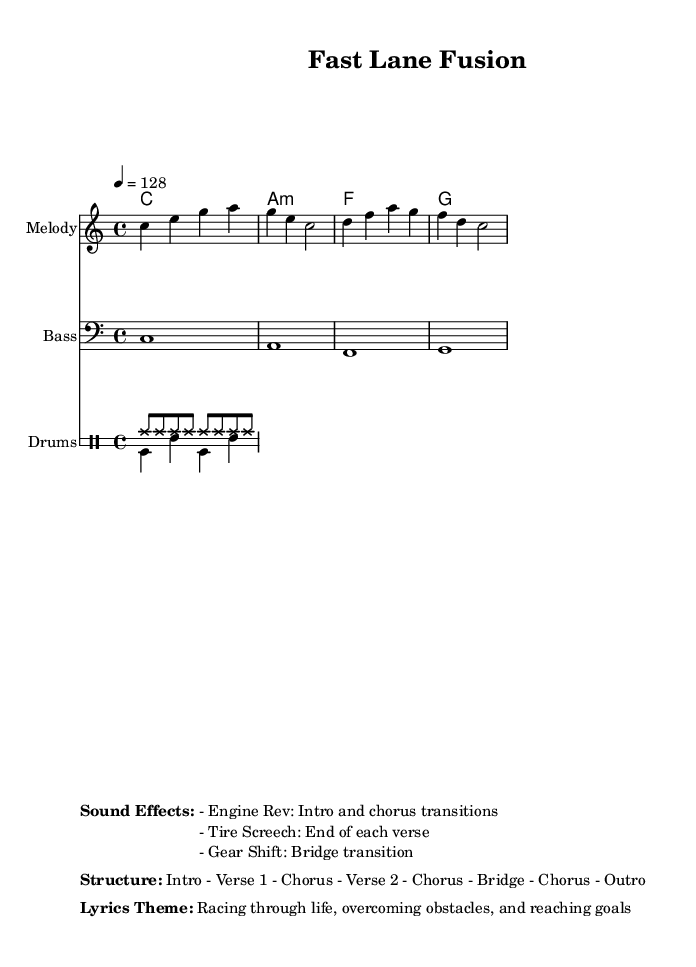What is the key signature of this music? The key signature is indicated as C major, which is shown near the beginning of the sheet music. It has no sharps or flats, confirming the key of C major.
Answer: C major What is the time signature of the music? The time signature is shown right after the key signature, indicated by the number of beats per measure and the note that gets the beat. In this case, it is 4/4, meaning there are four beats in each measure and the quarter note gets one beat.
Answer: 4/4 What is the tempo of the piece? The tempo is stated in beats per minute and is usually found near the top of the music sheet. Here it is indicated as 4 = 128, meaning there are 128 beats per minute.
Answer: 128 How many sections are in the song structure? The song structure is provided in the markup section, detailing the arrangement of the music. The structure given is "Intro - Verse 1 - Chorus - Verse 2 - Chorus - Bridge - Chorus - Outro." Counting these sections gives a total of seven distinct parts.
Answer: 7 What sound effect is used in the intro and chorus transitions? The sound effect list in the markup specifies that the "Engine Rev" sound effect is used during the intro and the chorus transitions of the song, highlighted in the sound effects section.
Answer: Engine Rev What theme do the lyrics convey? The lyrics theme is articulated in the markup section, which describes the focus of the lyrics: "Racing through life, overcoming obstacles, and reaching goals." This encapsulates the motivational aspect often found in pop music.
Answer: Racing through life 